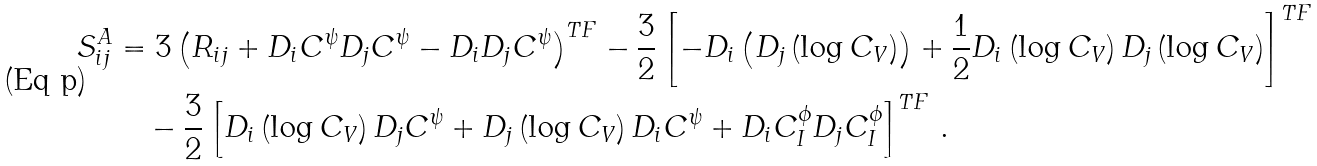Convert formula to latex. <formula><loc_0><loc_0><loc_500><loc_500>S _ { i j } ^ { A } & = 3 \left ( R _ { i j } + D _ { i } C ^ { \psi } D _ { j } C ^ { \psi } - D _ { i } D _ { j } C ^ { \psi } \right ) ^ { T F } - \frac { 3 } { 2 } \left [ - D _ { i } \left ( D _ { j } \left ( \log C _ { V } \right ) \right ) + \frac { 1 } { 2 } D _ { i } \left ( \log C _ { V } \right ) D _ { j } \left ( \log C _ { V } \right ) \right ] ^ { T F } \\ & \quad - \frac { 3 } { 2 } \left [ D _ { i } \left ( \log C _ { V } \right ) D _ { j } C ^ { \psi } + D _ { j } \left ( \log C _ { V } \right ) D _ { i } C ^ { \psi } + D _ { i } C _ { I } ^ { \phi } D _ { j } C _ { I } ^ { \phi } \right ] ^ { T F } \, .</formula> 